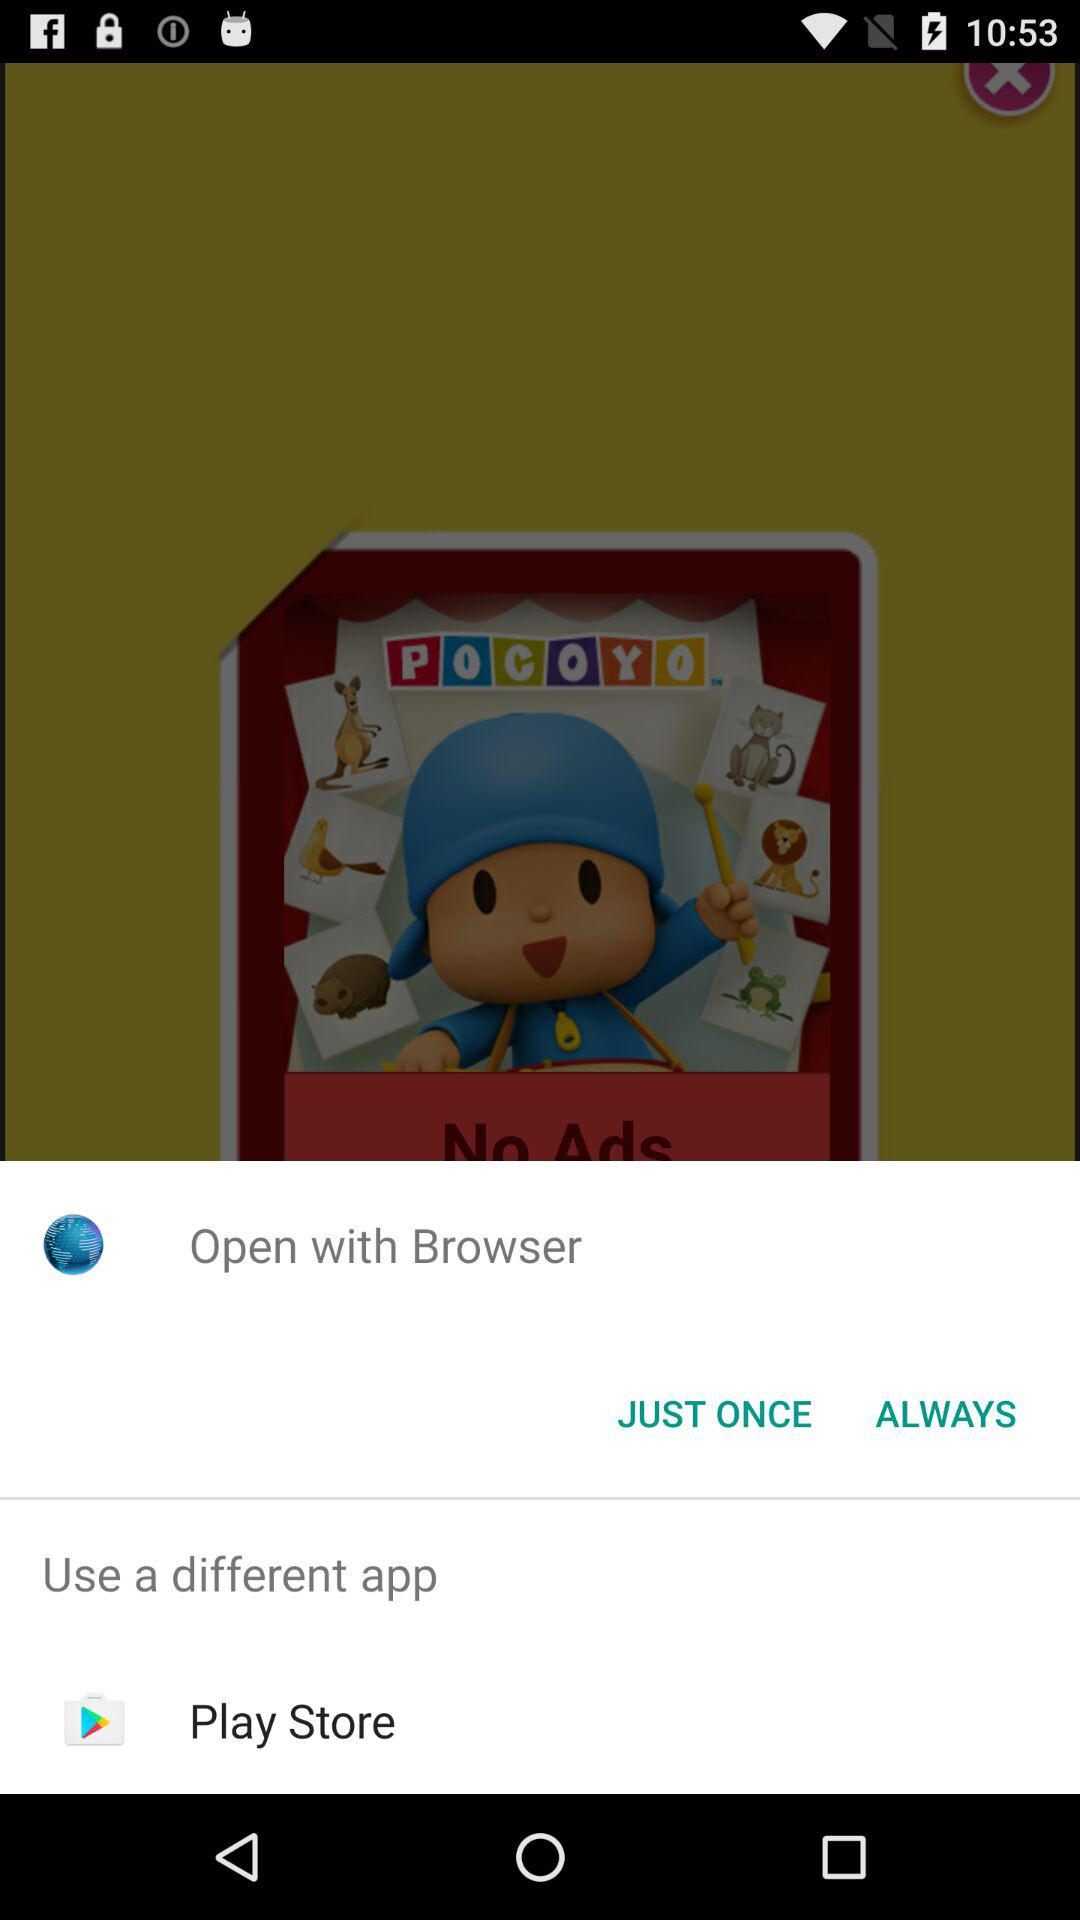How many options are given for opening the app?
Answer the question using a single word or phrase. 3 